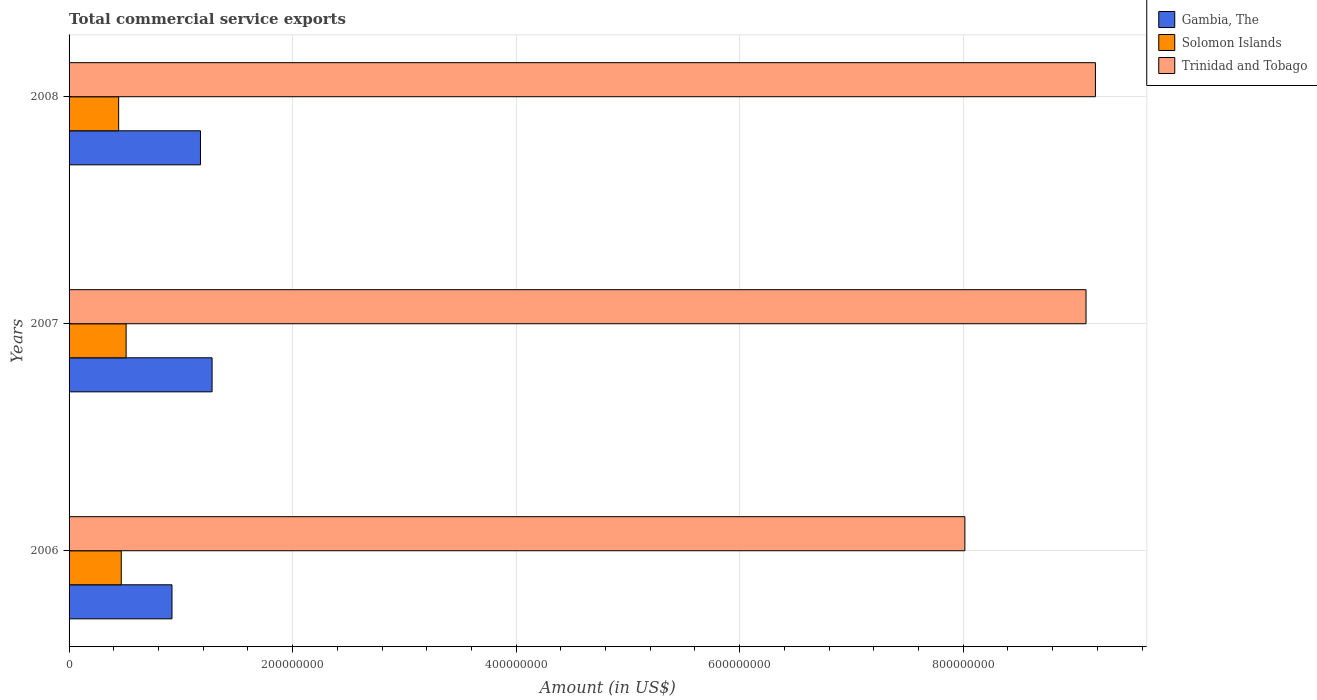How many different coloured bars are there?
Make the answer very short. 3. How many groups of bars are there?
Make the answer very short. 3. How many bars are there on the 1st tick from the bottom?
Provide a succinct answer. 3. What is the label of the 1st group of bars from the top?
Ensure brevity in your answer.  2008. In how many cases, is the number of bars for a given year not equal to the number of legend labels?
Provide a succinct answer. 0. What is the total commercial service exports in Solomon Islands in 2006?
Your answer should be very brief. 4.67e+07. Across all years, what is the maximum total commercial service exports in Solomon Islands?
Ensure brevity in your answer.  5.10e+07. Across all years, what is the minimum total commercial service exports in Solomon Islands?
Your answer should be compact. 4.44e+07. In which year was the total commercial service exports in Trinidad and Tobago maximum?
Provide a short and direct response. 2008. In which year was the total commercial service exports in Trinidad and Tobago minimum?
Offer a terse response. 2006. What is the total total commercial service exports in Trinidad and Tobago in the graph?
Your answer should be compact. 2.63e+09. What is the difference between the total commercial service exports in Trinidad and Tobago in 2006 and that in 2008?
Provide a short and direct response. -1.17e+08. What is the difference between the total commercial service exports in Gambia, The in 2008 and the total commercial service exports in Solomon Islands in 2007?
Keep it short and to the point. 6.65e+07. What is the average total commercial service exports in Gambia, The per year?
Keep it short and to the point. 1.13e+08. In the year 2006, what is the difference between the total commercial service exports in Trinidad and Tobago and total commercial service exports in Gambia, The?
Ensure brevity in your answer.  7.09e+08. What is the ratio of the total commercial service exports in Solomon Islands in 2007 to that in 2008?
Keep it short and to the point. 1.15. Is the difference between the total commercial service exports in Trinidad and Tobago in 2007 and 2008 greater than the difference between the total commercial service exports in Gambia, The in 2007 and 2008?
Ensure brevity in your answer.  No. What is the difference between the highest and the second highest total commercial service exports in Gambia, The?
Offer a very short reply. 1.04e+07. What is the difference between the highest and the lowest total commercial service exports in Solomon Islands?
Ensure brevity in your answer.  6.67e+06. In how many years, is the total commercial service exports in Trinidad and Tobago greater than the average total commercial service exports in Trinidad and Tobago taken over all years?
Provide a succinct answer. 2. What does the 3rd bar from the top in 2008 represents?
Provide a short and direct response. Gambia, The. What does the 2nd bar from the bottom in 2006 represents?
Offer a very short reply. Solomon Islands. Is it the case that in every year, the sum of the total commercial service exports in Trinidad and Tobago and total commercial service exports in Gambia, The is greater than the total commercial service exports in Solomon Islands?
Make the answer very short. Yes. What is the difference between two consecutive major ticks on the X-axis?
Give a very brief answer. 2.00e+08. Are the values on the major ticks of X-axis written in scientific E-notation?
Your response must be concise. No. Does the graph contain any zero values?
Give a very brief answer. No. Does the graph contain grids?
Provide a short and direct response. Yes. Where does the legend appear in the graph?
Keep it short and to the point. Top right. How many legend labels are there?
Make the answer very short. 3. What is the title of the graph?
Offer a terse response. Total commercial service exports. What is the label or title of the X-axis?
Offer a very short reply. Amount (in US$). What is the Amount (in US$) in Gambia, The in 2006?
Your answer should be very brief. 9.21e+07. What is the Amount (in US$) of Solomon Islands in 2006?
Give a very brief answer. 4.67e+07. What is the Amount (in US$) in Trinidad and Tobago in 2006?
Your answer should be compact. 8.02e+08. What is the Amount (in US$) in Gambia, The in 2007?
Your answer should be very brief. 1.28e+08. What is the Amount (in US$) in Solomon Islands in 2007?
Your answer should be compact. 5.10e+07. What is the Amount (in US$) of Trinidad and Tobago in 2007?
Your answer should be very brief. 9.10e+08. What is the Amount (in US$) of Gambia, The in 2008?
Give a very brief answer. 1.18e+08. What is the Amount (in US$) of Solomon Islands in 2008?
Your answer should be very brief. 4.44e+07. What is the Amount (in US$) in Trinidad and Tobago in 2008?
Provide a short and direct response. 9.18e+08. Across all years, what is the maximum Amount (in US$) of Gambia, The?
Your answer should be compact. 1.28e+08. Across all years, what is the maximum Amount (in US$) of Solomon Islands?
Give a very brief answer. 5.10e+07. Across all years, what is the maximum Amount (in US$) in Trinidad and Tobago?
Your response must be concise. 9.18e+08. Across all years, what is the minimum Amount (in US$) in Gambia, The?
Offer a terse response. 9.21e+07. Across all years, what is the minimum Amount (in US$) in Solomon Islands?
Keep it short and to the point. 4.44e+07. Across all years, what is the minimum Amount (in US$) in Trinidad and Tobago?
Give a very brief answer. 8.02e+08. What is the total Amount (in US$) in Gambia, The in the graph?
Your answer should be very brief. 3.38e+08. What is the total Amount (in US$) of Solomon Islands in the graph?
Offer a terse response. 1.42e+08. What is the total Amount (in US$) in Trinidad and Tobago in the graph?
Give a very brief answer. 2.63e+09. What is the difference between the Amount (in US$) of Gambia, The in 2006 and that in 2007?
Offer a terse response. -3.59e+07. What is the difference between the Amount (in US$) in Solomon Islands in 2006 and that in 2007?
Your answer should be compact. -4.36e+06. What is the difference between the Amount (in US$) of Trinidad and Tobago in 2006 and that in 2007?
Your response must be concise. -1.08e+08. What is the difference between the Amount (in US$) in Gambia, The in 2006 and that in 2008?
Your answer should be very brief. -2.55e+07. What is the difference between the Amount (in US$) in Solomon Islands in 2006 and that in 2008?
Keep it short and to the point. 2.32e+06. What is the difference between the Amount (in US$) of Trinidad and Tobago in 2006 and that in 2008?
Provide a succinct answer. -1.17e+08. What is the difference between the Amount (in US$) in Gambia, The in 2007 and that in 2008?
Your answer should be compact. 1.04e+07. What is the difference between the Amount (in US$) of Solomon Islands in 2007 and that in 2008?
Your answer should be very brief. 6.67e+06. What is the difference between the Amount (in US$) of Trinidad and Tobago in 2007 and that in 2008?
Give a very brief answer. -8.40e+06. What is the difference between the Amount (in US$) of Gambia, The in 2006 and the Amount (in US$) of Solomon Islands in 2007?
Make the answer very short. 4.10e+07. What is the difference between the Amount (in US$) of Gambia, The in 2006 and the Amount (in US$) of Trinidad and Tobago in 2007?
Offer a very short reply. -8.18e+08. What is the difference between the Amount (in US$) in Solomon Islands in 2006 and the Amount (in US$) in Trinidad and Tobago in 2007?
Offer a very short reply. -8.63e+08. What is the difference between the Amount (in US$) in Gambia, The in 2006 and the Amount (in US$) in Solomon Islands in 2008?
Provide a succinct answer. 4.77e+07. What is the difference between the Amount (in US$) of Gambia, The in 2006 and the Amount (in US$) of Trinidad and Tobago in 2008?
Offer a very short reply. -8.26e+08. What is the difference between the Amount (in US$) in Solomon Islands in 2006 and the Amount (in US$) in Trinidad and Tobago in 2008?
Give a very brief answer. -8.72e+08. What is the difference between the Amount (in US$) of Gambia, The in 2007 and the Amount (in US$) of Solomon Islands in 2008?
Offer a very short reply. 8.36e+07. What is the difference between the Amount (in US$) in Gambia, The in 2007 and the Amount (in US$) in Trinidad and Tobago in 2008?
Ensure brevity in your answer.  -7.90e+08. What is the difference between the Amount (in US$) in Solomon Islands in 2007 and the Amount (in US$) in Trinidad and Tobago in 2008?
Make the answer very short. -8.67e+08. What is the average Amount (in US$) of Gambia, The per year?
Make the answer very short. 1.13e+08. What is the average Amount (in US$) of Solomon Islands per year?
Give a very brief answer. 4.74e+07. What is the average Amount (in US$) in Trinidad and Tobago per year?
Give a very brief answer. 8.77e+08. In the year 2006, what is the difference between the Amount (in US$) in Gambia, The and Amount (in US$) in Solomon Islands?
Offer a terse response. 4.54e+07. In the year 2006, what is the difference between the Amount (in US$) of Gambia, The and Amount (in US$) of Trinidad and Tobago?
Offer a very short reply. -7.09e+08. In the year 2006, what is the difference between the Amount (in US$) of Solomon Islands and Amount (in US$) of Trinidad and Tobago?
Your response must be concise. -7.55e+08. In the year 2007, what is the difference between the Amount (in US$) in Gambia, The and Amount (in US$) in Solomon Islands?
Keep it short and to the point. 7.69e+07. In the year 2007, what is the difference between the Amount (in US$) of Gambia, The and Amount (in US$) of Trinidad and Tobago?
Your response must be concise. -7.82e+08. In the year 2007, what is the difference between the Amount (in US$) in Solomon Islands and Amount (in US$) in Trinidad and Tobago?
Provide a short and direct response. -8.59e+08. In the year 2008, what is the difference between the Amount (in US$) in Gambia, The and Amount (in US$) in Solomon Islands?
Your answer should be compact. 7.32e+07. In the year 2008, what is the difference between the Amount (in US$) in Gambia, The and Amount (in US$) in Trinidad and Tobago?
Give a very brief answer. -8.01e+08. In the year 2008, what is the difference between the Amount (in US$) in Solomon Islands and Amount (in US$) in Trinidad and Tobago?
Keep it short and to the point. -8.74e+08. What is the ratio of the Amount (in US$) of Gambia, The in 2006 to that in 2007?
Ensure brevity in your answer.  0.72. What is the ratio of the Amount (in US$) in Solomon Islands in 2006 to that in 2007?
Provide a short and direct response. 0.91. What is the ratio of the Amount (in US$) of Trinidad and Tobago in 2006 to that in 2007?
Make the answer very short. 0.88. What is the ratio of the Amount (in US$) in Gambia, The in 2006 to that in 2008?
Give a very brief answer. 0.78. What is the ratio of the Amount (in US$) in Solomon Islands in 2006 to that in 2008?
Ensure brevity in your answer.  1.05. What is the ratio of the Amount (in US$) in Trinidad and Tobago in 2006 to that in 2008?
Your response must be concise. 0.87. What is the ratio of the Amount (in US$) of Gambia, The in 2007 to that in 2008?
Offer a terse response. 1.09. What is the ratio of the Amount (in US$) in Solomon Islands in 2007 to that in 2008?
Your answer should be compact. 1.15. What is the ratio of the Amount (in US$) in Trinidad and Tobago in 2007 to that in 2008?
Your response must be concise. 0.99. What is the difference between the highest and the second highest Amount (in US$) in Gambia, The?
Give a very brief answer. 1.04e+07. What is the difference between the highest and the second highest Amount (in US$) in Solomon Islands?
Your answer should be compact. 4.36e+06. What is the difference between the highest and the second highest Amount (in US$) of Trinidad and Tobago?
Make the answer very short. 8.40e+06. What is the difference between the highest and the lowest Amount (in US$) of Gambia, The?
Offer a terse response. 3.59e+07. What is the difference between the highest and the lowest Amount (in US$) in Solomon Islands?
Offer a terse response. 6.67e+06. What is the difference between the highest and the lowest Amount (in US$) in Trinidad and Tobago?
Ensure brevity in your answer.  1.17e+08. 